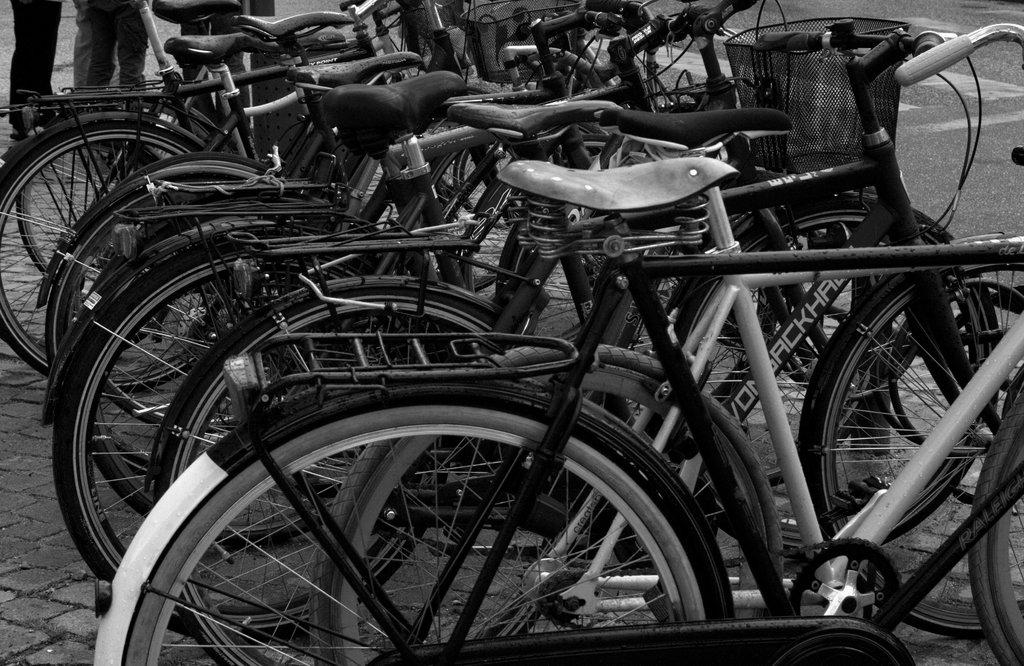What type of vehicles are in the image? There are bicycles in the image. Can you describe the people in the image? The legs of persons are visible in the image. What is the color scheme of the image? The image is in black and white. What type of planes can be seen flying in the image? There are no planes visible in the image; it features bicycles and legs of persons. What is the weather like in the image, considering the presence of the sun? There is no sun present in the image, as it is in black and white. 